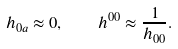<formula> <loc_0><loc_0><loc_500><loc_500>h _ { 0 a } \approx 0 , \quad h ^ { 0 0 } \approx \frac { 1 } { h _ { 0 0 } } .</formula> 